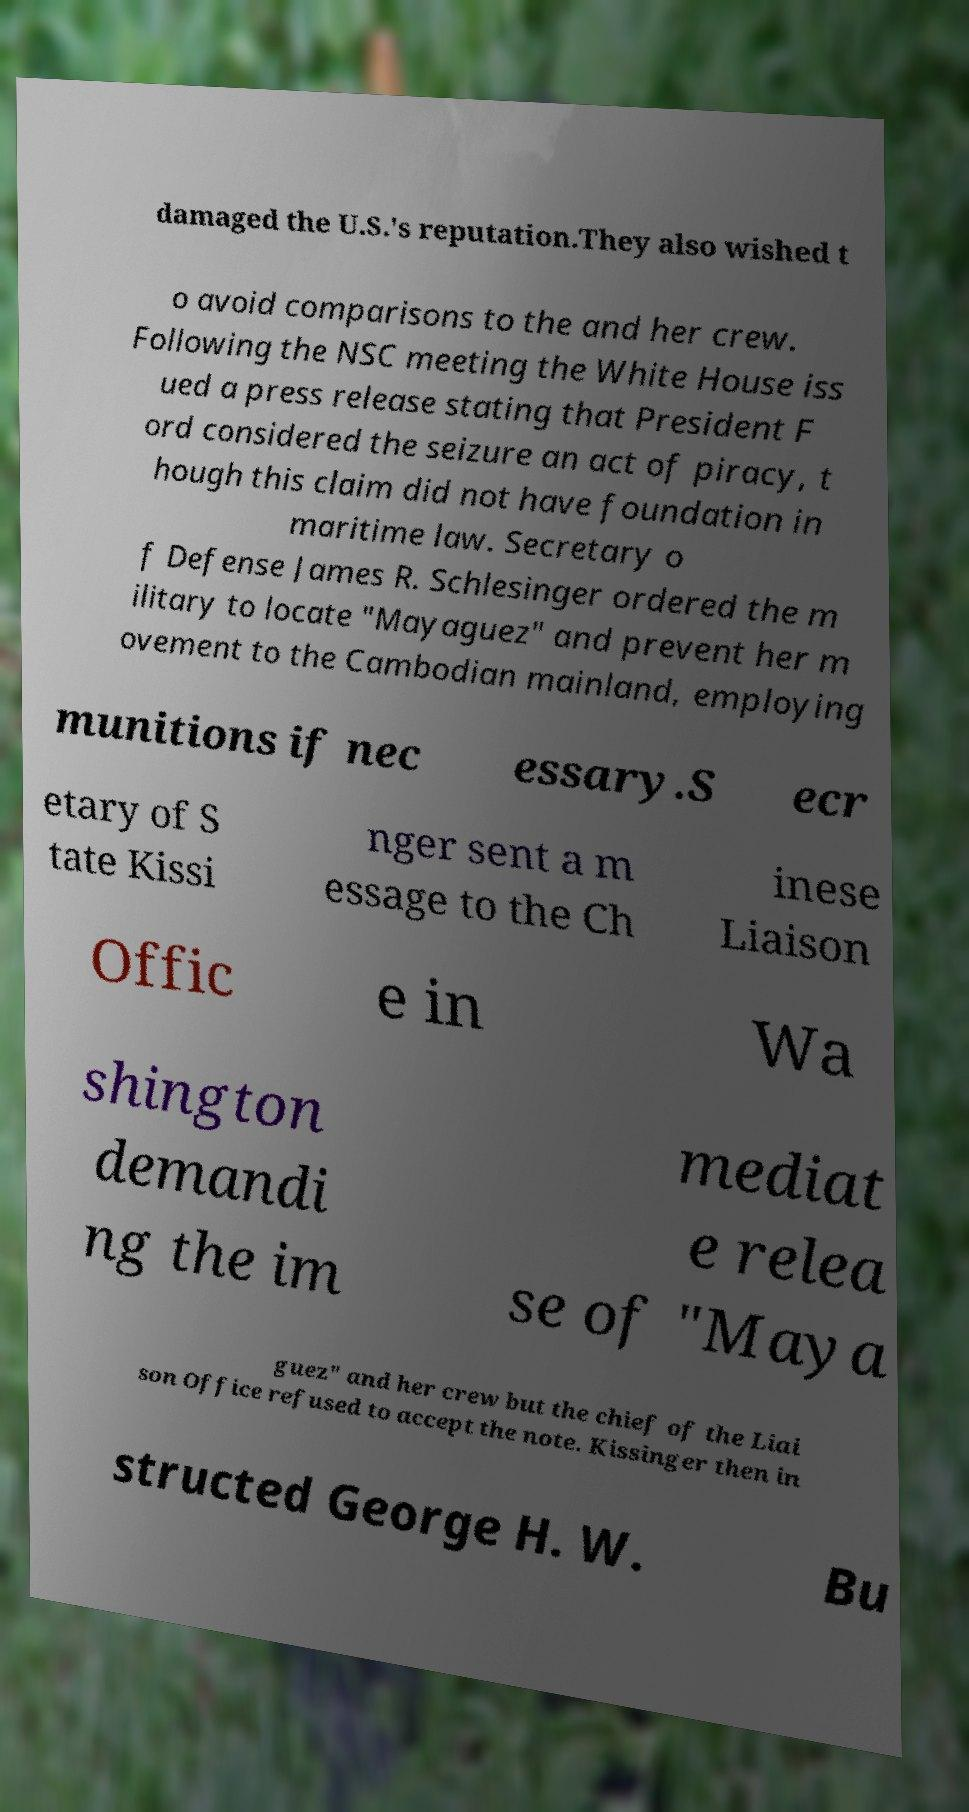There's text embedded in this image that I need extracted. Can you transcribe it verbatim? damaged the U.S.'s reputation.They also wished t o avoid comparisons to the and her crew. Following the NSC meeting the White House iss ued a press release stating that President F ord considered the seizure an act of piracy, t hough this claim did not have foundation in maritime law. Secretary o f Defense James R. Schlesinger ordered the m ilitary to locate "Mayaguez" and prevent her m ovement to the Cambodian mainland, employing munitions if nec essary.S ecr etary of S tate Kissi nger sent a m essage to the Ch inese Liaison Offic e in Wa shington demandi ng the im mediat e relea se of "Maya guez" and her crew but the chief of the Liai son Office refused to accept the note. Kissinger then in structed George H. W. Bu 